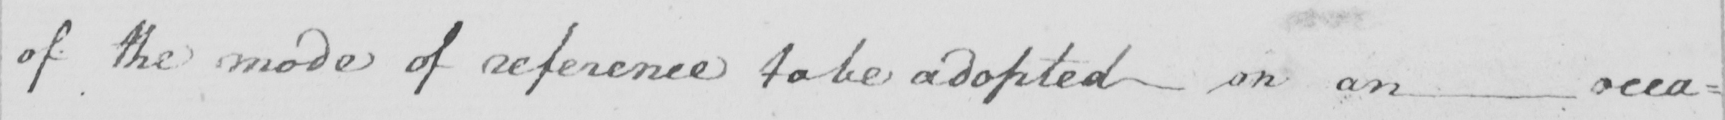Please transcribe the handwritten text in this image. of the mode of reference to be adopted on an occa : 